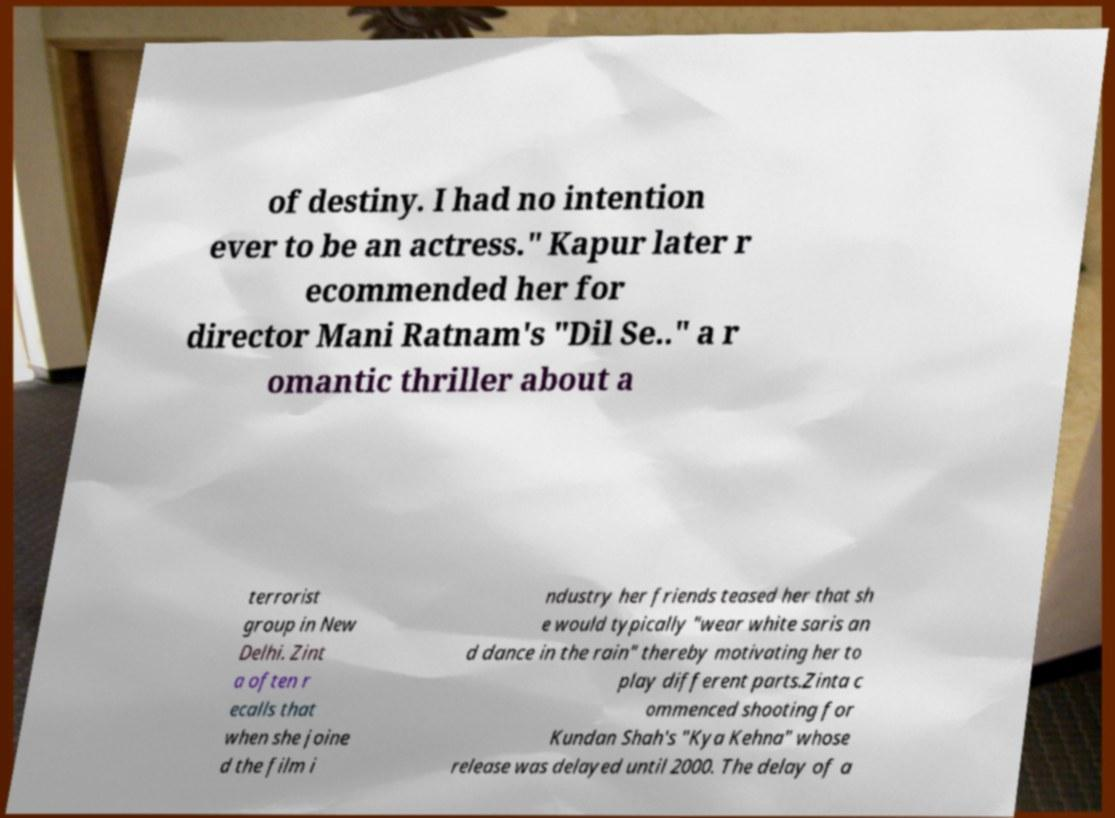There's text embedded in this image that I need extracted. Can you transcribe it verbatim? of destiny. I had no intention ever to be an actress." Kapur later r ecommended her for director Mani Ratnam's "Dil Se.." a r omantic thriller about a terrorist group in New Delhi. Zint a often r ecalls that when she joine d the film i ndustry her friends teased her that sh e would typically "wear white saris an d dance in the rain" thereby motivating her to play different parts.Zinta c ommenced shooting for Kundan Shah's "Kya Kehna" whose release was delayed until 2000. The delay of a 